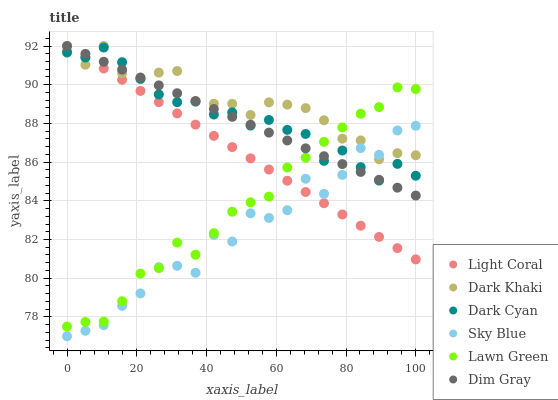Does Sky Blue have the minimum area under the curve?
Answer yes or no. Yes. Does Dark Khaki have the maximum area under the curve?
Answer yes or no. Yes. Does Dim Gray have the minimum area under the curve?
Answer yes or no. No. Does Dim Gray have the maximum area under the curve?
Answer yes or no. No. Is Dim Gray the smoothest?
Answer yes or no. Yes. Is Sky Blue the roughest?
Answer yes or no. Yes. Is Lawn Green the smoothest?
Answer yes or no. No. Is Lawn Green the roughest?
Answer yes or no. No. Does Sky Blue have the lowest value?
Answer yes or no. Yes. Does Dim Gray have the lowest value?
Answer yes or no. No. Does Light Coral have the highest value?
Answer yes or no. Yes. Does Lawn Green have the highest value?
Answer yes or no. No. Does Dim Gray intersect Dark Khaki?
Answer yes or no. Yes. Is Dim Gray less than Dark Khaki?
Answer yes or no. No. Is Dim Gray greater than Dark Khaki?
Answer yes or no. No. 